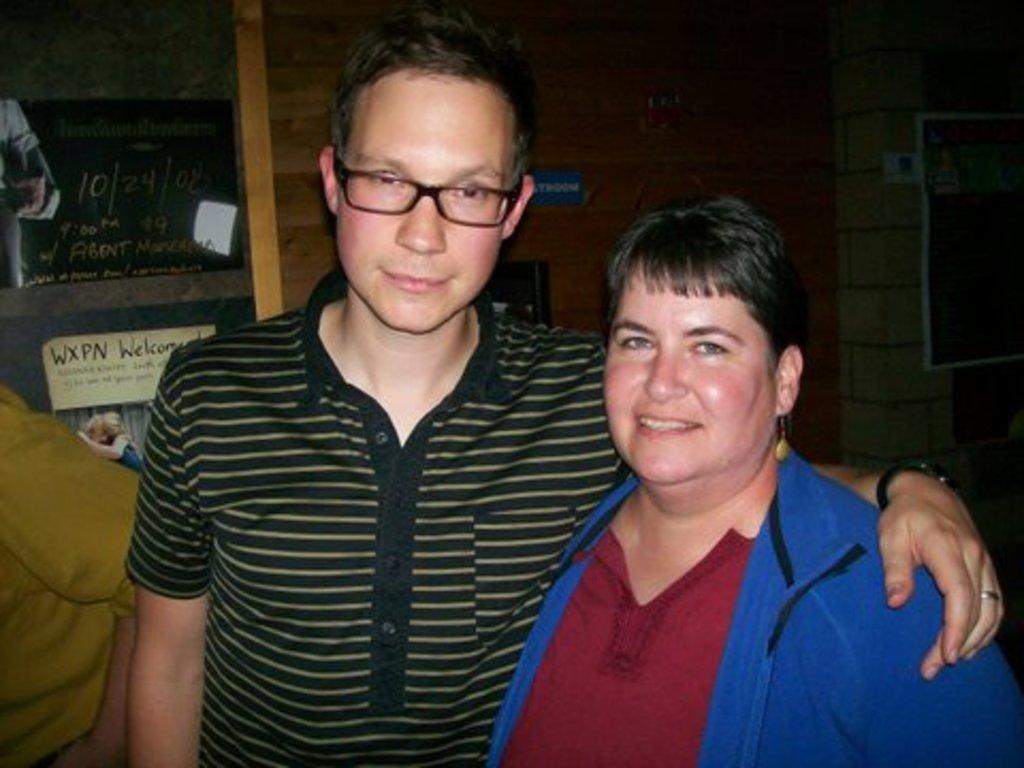In one or two sentences, can you explain what this image depicts? In the picture we can see a man and a woman standing and woman is smiling and in the background we can see a wall which is made up of a wooden. 